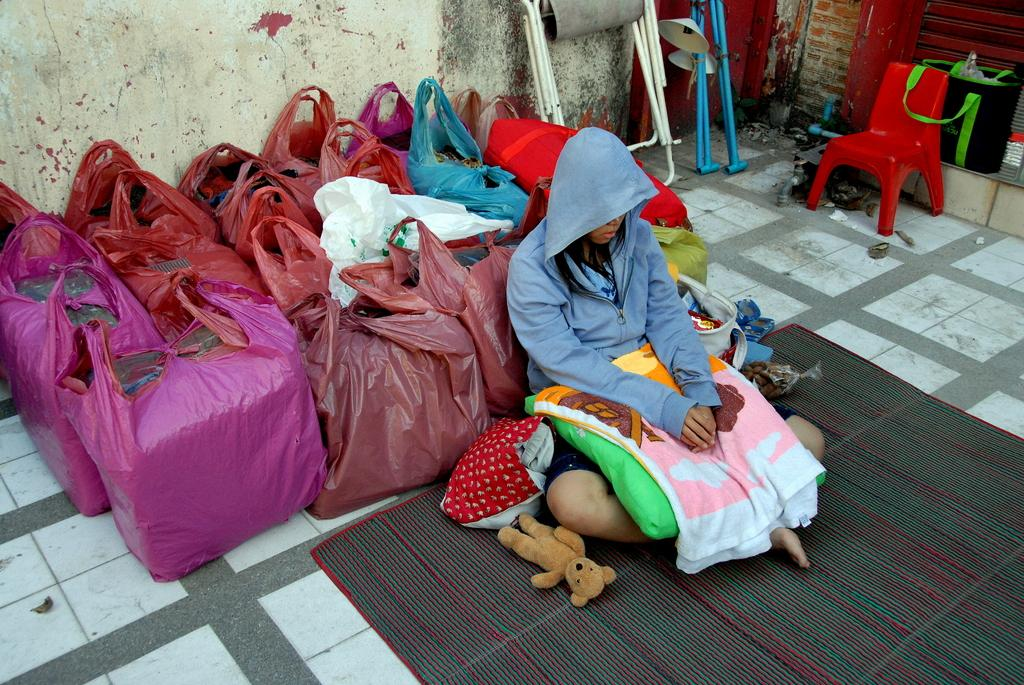What is the person in the image doing? There is a person sitting on a mat in the image. What might the person be using to carry items? There are carry bags in the image. What type of furniture is present in the image? There are chairs in the image. What else can be seen in the image besides the person, carry bags, and chairs? There are other objects in the image. What is visible in the background of the image? There is a wall visible in the image. What type of cheese is being used to quiet the force in the image? There is no cheese, force, or quieting action present in the image. 